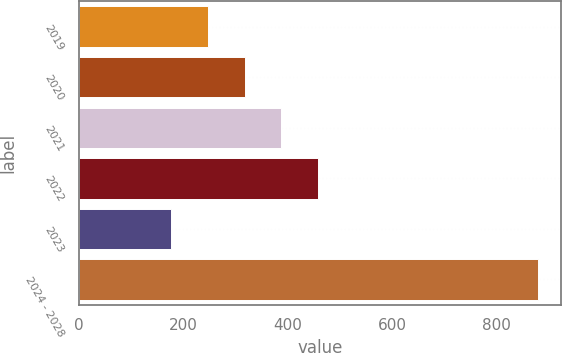Convert chart to OTSL. <chart><loc_0><loc_0><loc_500><loc_500><bar_chart><fcel>2019<fcel>2020<fcel>2021<fcel>2022<fcel>2023<fcel>2024 - 2028<nl><fcel>247.2<fcel>317.4<fcel>387.6<fcel>457.8<fcel>177<fcel>879<nl></chart> 